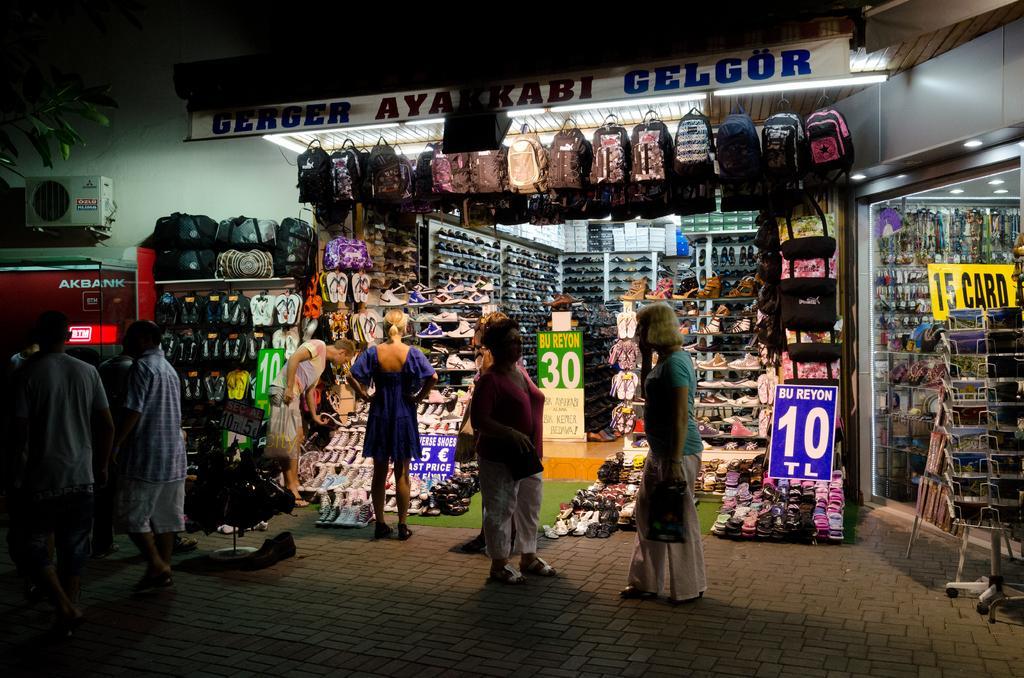Could you give a brief overview of what you see in this image? In this picture there are people and we can see shops, footwear, bags, boards, device, wall and objects. 